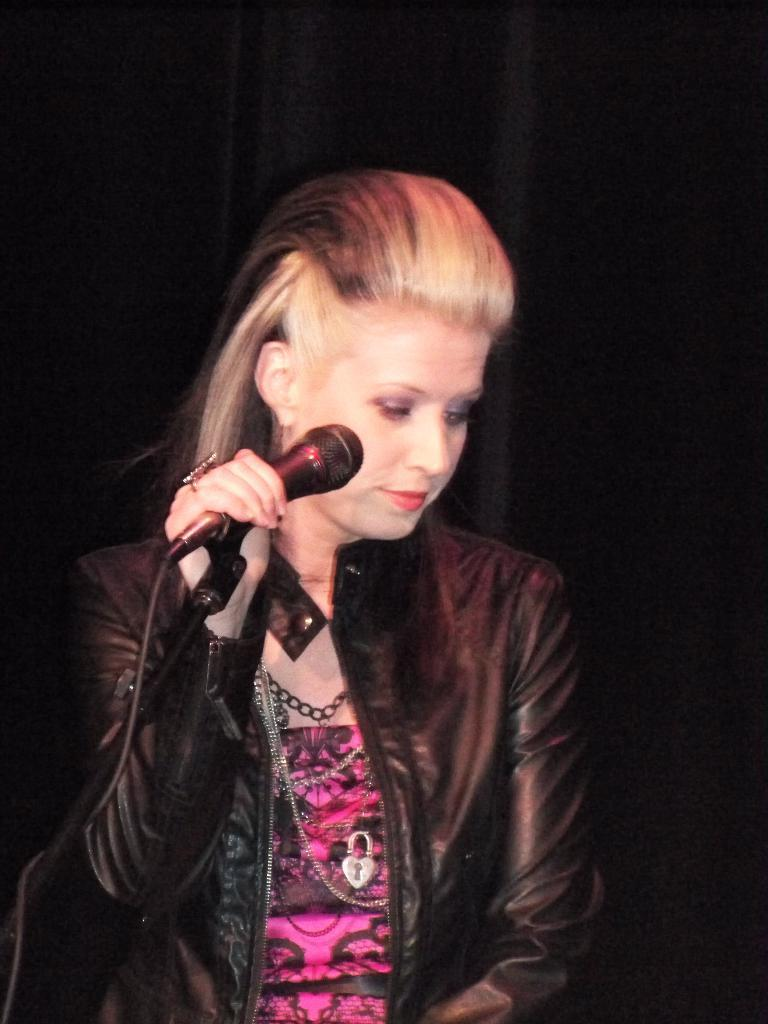Who is the main subject in the image? There is a woman in the image. What is the woman wearing? The woman is wearing a jacket and chains. What is the woman holding in the image? The woman is holding a microphone. What is the woman's posture or expression in the image? The woman is looking downwards. What type of pig is guiding the woman in the image? There is no pig present in the image, and the woman is not being guided by any animal. 